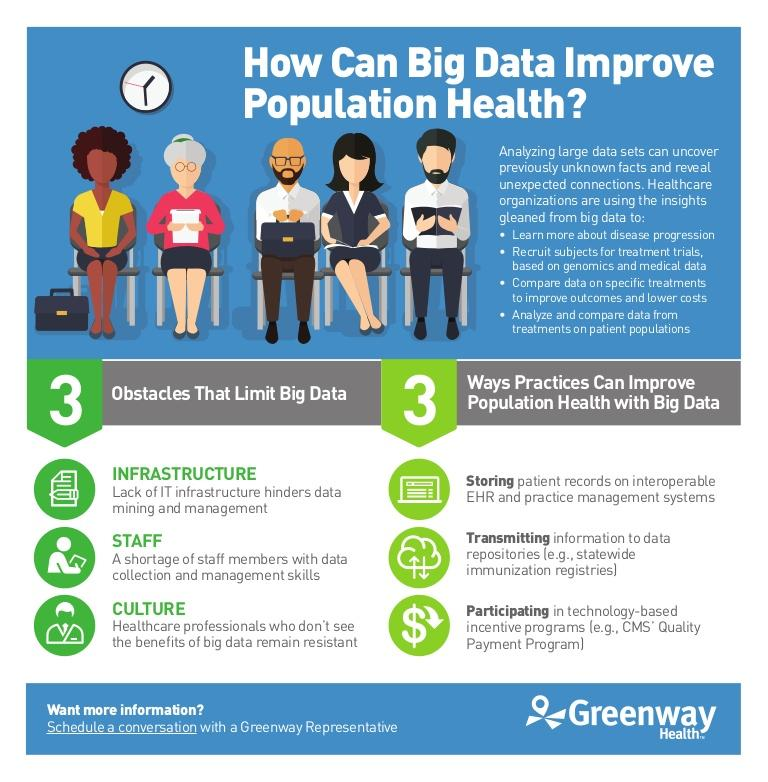Mention a couple of crucial points in this snapshot. A statewide immunization registry is an example of a data repository, which is a system or collection of systems used to store and manage data. Healthcare organizations are able to perform four types of activities through the insights gleaned from big data. The limitations of big data are primarily due to infrastructure, staff, and cultural factors. 